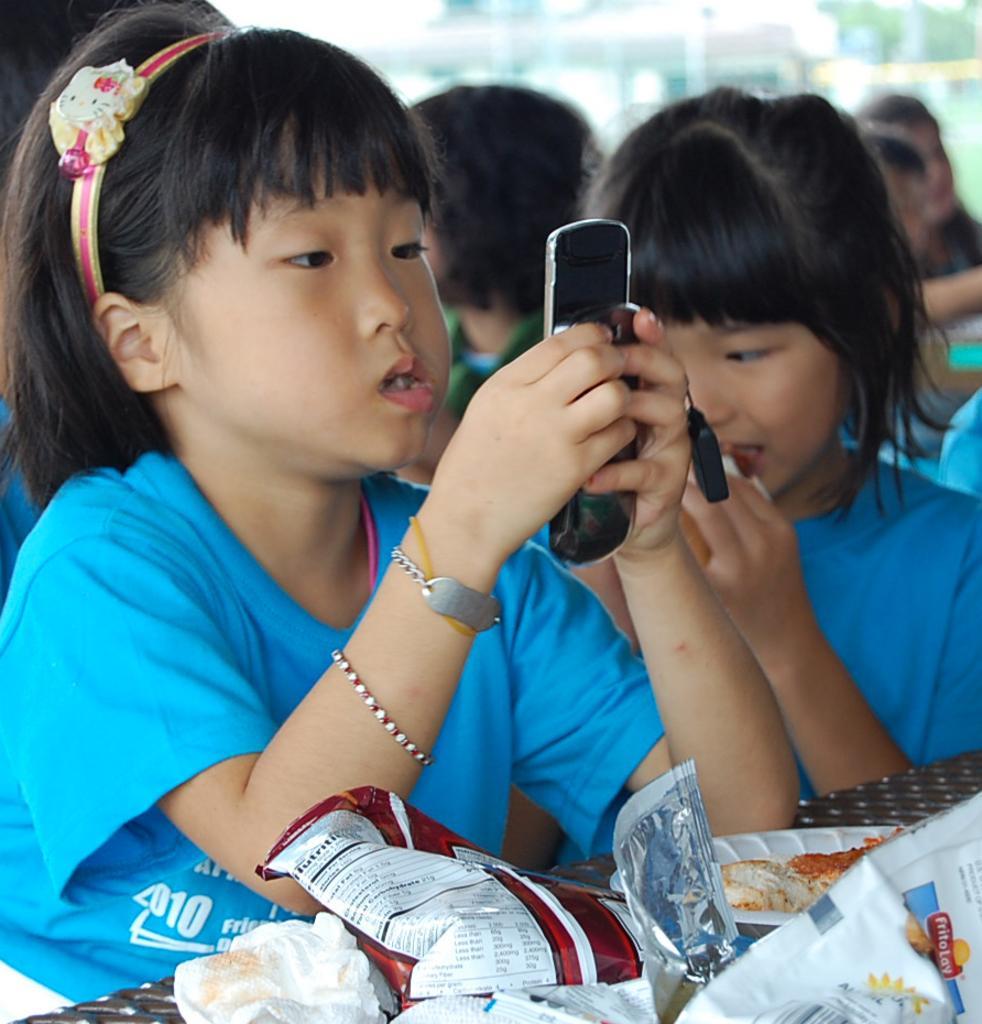How would you summarize this image in a sentence or two? In this image i can see a girl sitting and holding a cellphone in her hand. In the background i can see few people and trees. 